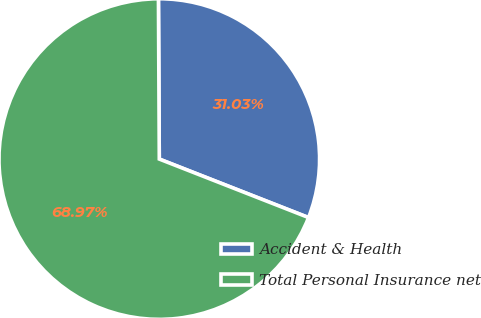<chart> <loc_0><loc_0><loc_500><loc_500><pie_chart><fcel>Accident & Health<fcel>Total Personal Insurance net<nl><fcel>31.03%<fcel>68.97%<nl></chart> 